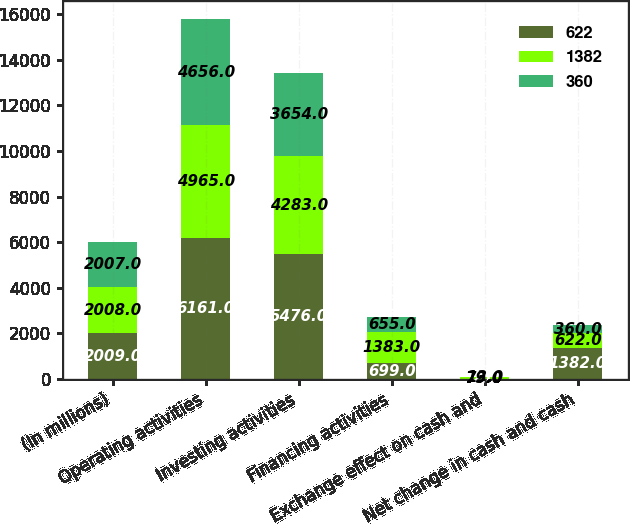Convert chart to OTSL. <chart><loc_0><loc_0><loc_500><loc_500><stacked_bar_chart><ecel><fcel>(In millions)<fcel>Operating activities<fcel>Investing activities<fcel>Financing activities<fcel>Exchange effect on cash and<fcel>Net change in cash and cash<nl><fcel>622<fcel>2009<fcel>6161<fcel>5476<fcel>699<fcel>2<fcel>1382<nl><fcel>1382<fcel>2008<fcel>4965<fcel>4283<fcel>1383<fcel>79<fcel>622<nl><fcel>360<fcel>2007<fcel>4656<fcel>3654<fcel>655<fcel>13<fcel>360<nl></chart> 